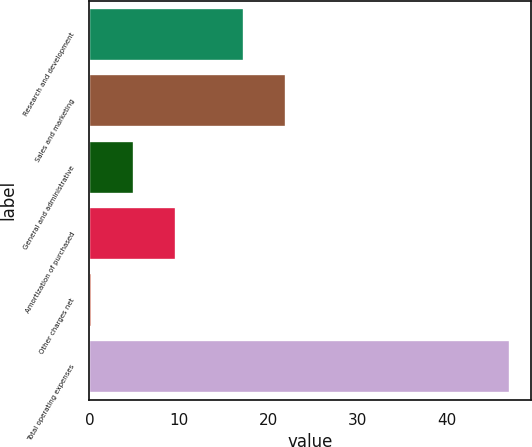Convert chart to OTSL. <chart><loc_0><loc_0><loc_500><loc_500><bar_chart><fcel>Research and development<fcel>Sales and marketing<fcel>General and administrative<fcel>Amortization of purchased<fcel>Other charges net<fcel>Total operating expenses<nl><fcel>17.3<fcel>21.97<fcel>4.97<fcel>9.64<fcel>0.3<fcel>47<nl></chart> 